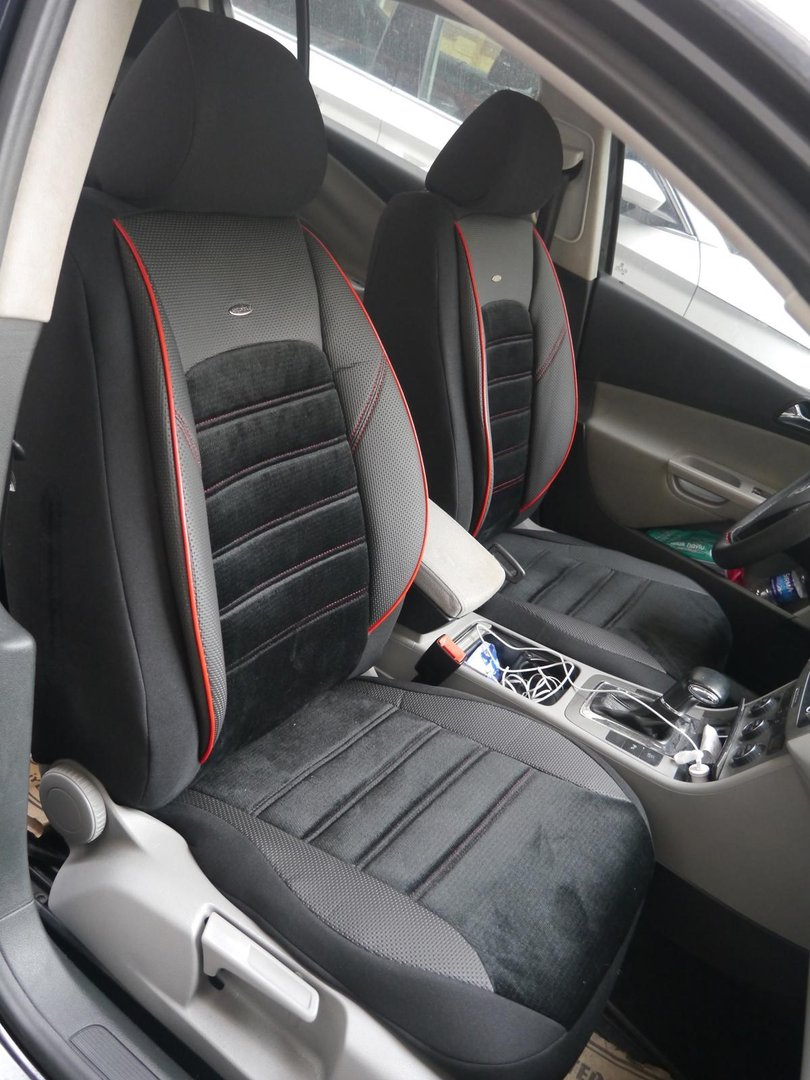What can be inferred about the car owner’s lifestyle based on the contents seen? From the contents visible in the car, several inferences can be made about the car owner's lifestyle. The presence of a charging cable suggests that the owner likely has a hectic or busy lifestyle, requiring them to charge their devices while on the go. The blue-capped item, which could be a water bottle or a cleaning spray, may indicate that the owner is health-conscious and prioritizes staying hydrated, or it could mean the owner values tidiness and maintains their car meticulously. Both items reflect a preference for convenience and preparedness in various aspects of life.  What kind of activities or daily routine could the owner have? Given the items in the car, it is reasonable to assume that the owner might have a lifestyle involving frequent travel, possibly for work or other commitments. They may need to stay connected to their devices for communication or navigation, hence the charging cable. If the blue-capped object is a water bottle, staying hydrated might be important, indicating activities like commuting, long drives, or a health-conscious routine. Alternatively, if it is a cleaning product, the owner might regularly engage in activities that require their vehicle to remain clean and presentable, suggesting a routine that values cleanliness and organization.  Describe a day in the life of this car owner using the clues from the car’s interior. A typical day for this car owner might start early with a morning commute to work. They might grab a quick breakfast, ensuring they bring along their water bottle to stay hydrated through the day. Throughout the day, they rely on their phone or other devices for communication, navigation, or entertainment, frequently using the charging cable to keep their devices powered up. The owner’s work might involve driving to various locations, making the car an essential part of their daily activities. After work, they might head to the gym, where keeping hydrated is important if the blue-capped item is indeed a water bottle. Ensuring their car remains tidy, they might use a cleaning spray to wipe down surfaces, maintaining cleanliness. This routine reflects a well-organized, health-conscious, and tech-reliant lifestyle, balancing work and personal well-being.  Imagine a wild scenario where the car and its items transform into a mission control center for a secret agent. Describe what the car’s interior reveals about their assignments and gadgets. In a fantastical twist, the car transforms into a high-tech mission control center for a secret agent. The charging cable is now a multipurpose gadget, capable of charging devices but also interfacing with the car’s advanced communication and surveillance systems. The blue-capped item, which was first thought to be a water bottle or cleaning spray, reveals its true use: a compact, versatile tool containing a powerful solvent that can dissolve locks or a liquid that emits a fine mist of sleep-inducing gas. The car's interior is lined with hidden compartments containing various gadgets like night vision glasses, tracking devices, and miniature drones. Even the seats are equipped with sensors and can send live data back to headquarters. This car is more than just a vehicle; it’s a mobile base of operations, enabling the agent to execute covert operations seamlessly while merging into the everyday urban landscape. 